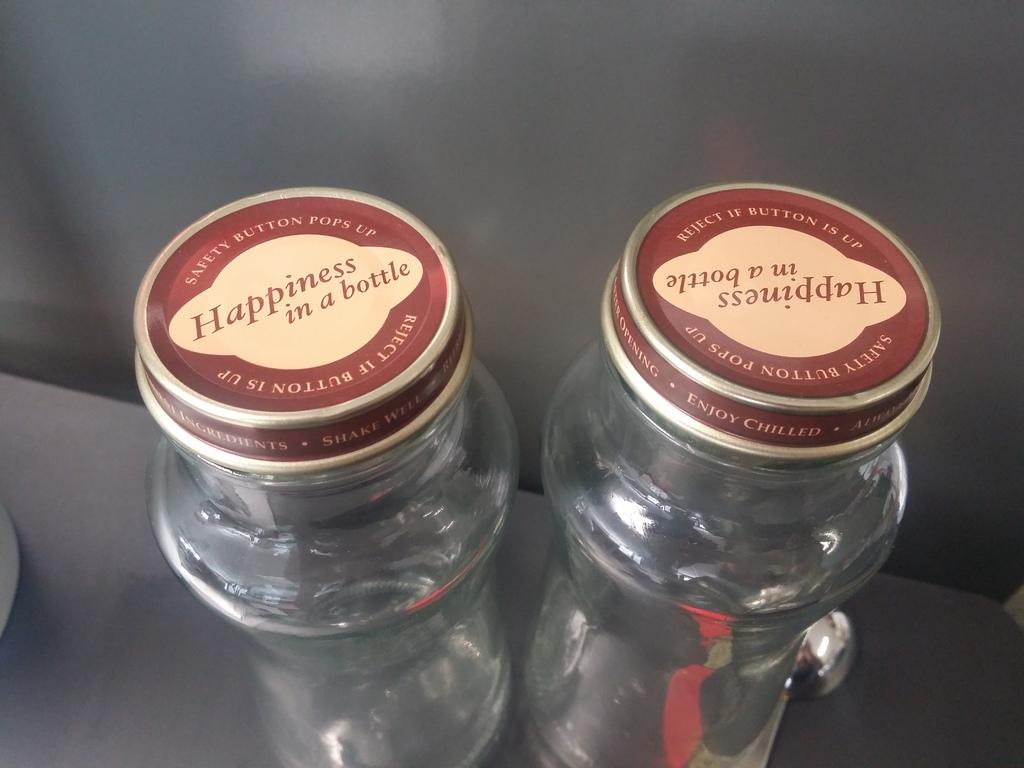What is claimed to be in the bottle?
Give a very brief answer. Happiness. What kind of button pops up?
Keep it short and to the point. Safety. 